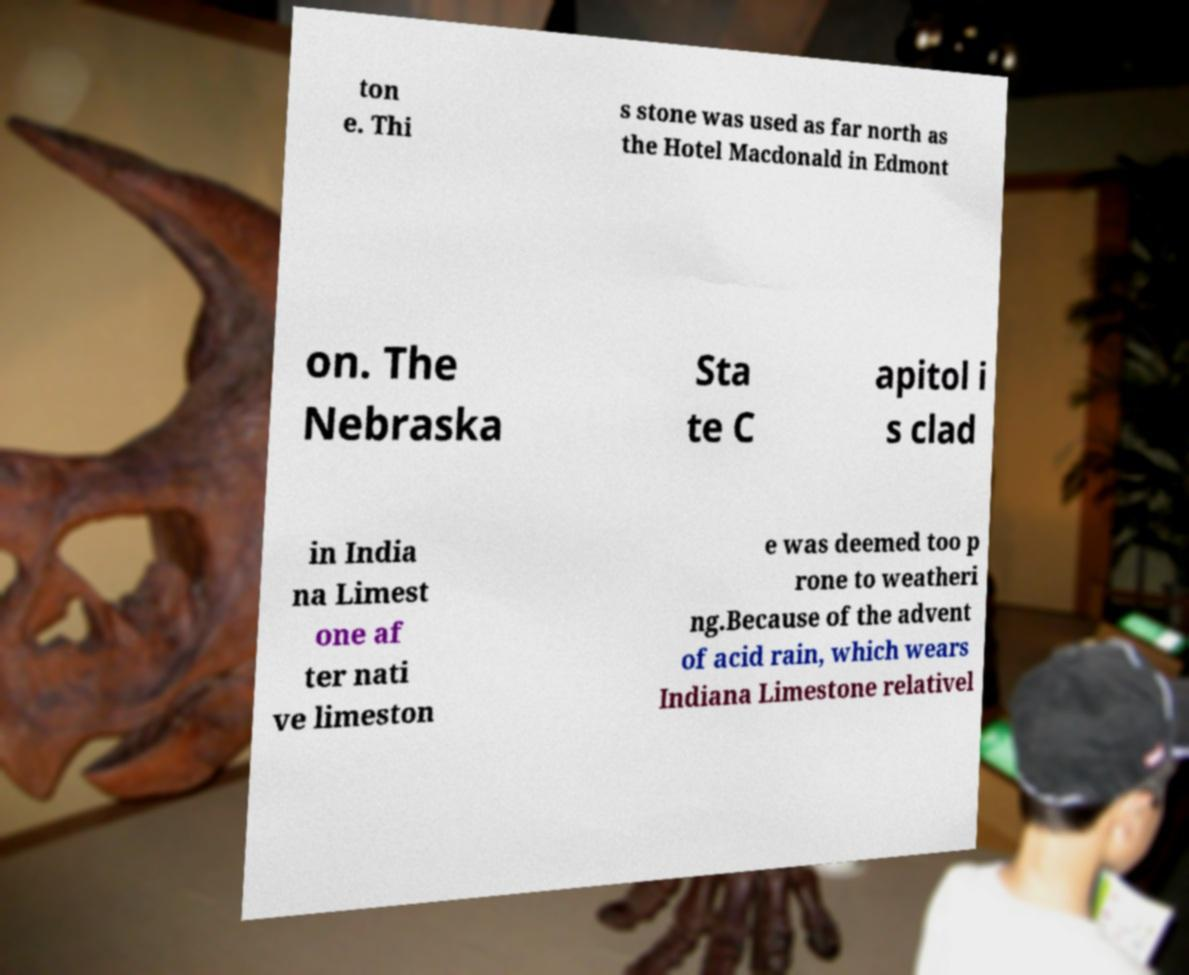Could you extract and type out the text from this image? ton e. Thi s stone was used as far north as the Hotel Macdonald in Edmont on. The Nebraska Sta te C apitol i s clad in India na Limest one af ter nati ve limeston e was deemed too p rone to weatheri ng.Because of the advent of acid rain, which wears Indiana Limestone relativel 